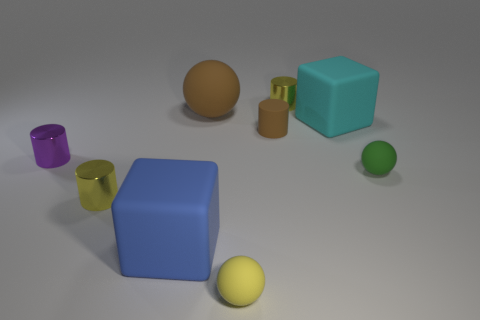Subtract all brown cylinders. How many cylinders are left? 3 Subtract all brown matte cylinders. How many cylinders are left? 3 Subtract 1 cylinders. How many cylinders are left? 3 Subtract all green cylinders. Subtract all purple cubes. How many cylinders are left? 4 Subtract all blocks. How many objects are left? 7 Add 1 tiny brown rubber cylinders. How many objects exist? 10 Add 1 large blue things. How many large blue things are left? 2 Add 4 big cyan cubes. How many big cyan cubes exist? 5 Subtract 0 blue balls. How many objects are left? 9 Subtract all big green matte things. Subtract all yellow balls. How many objects are left? 8 